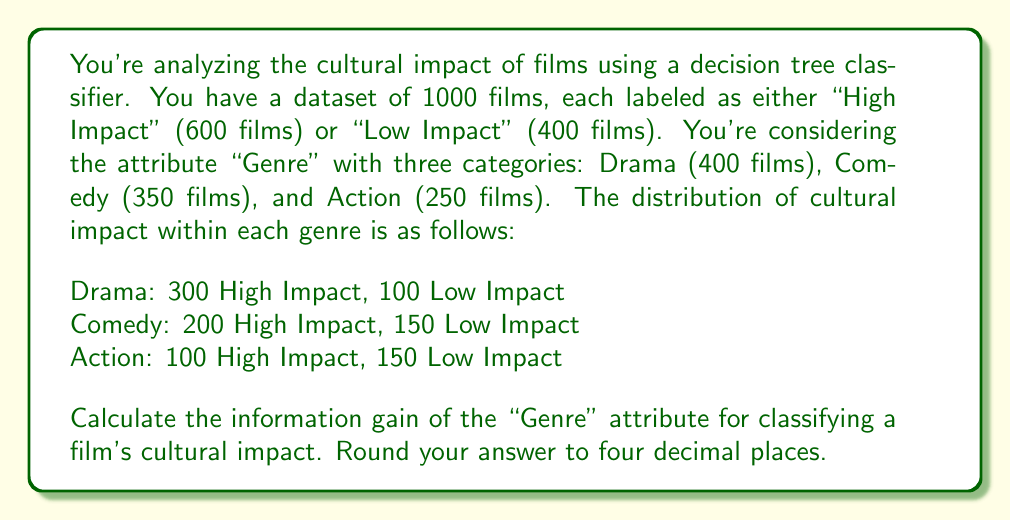Teach me how to tackle this problem. To calculate the information gain, we need to follow these steps:

1. Calculate the entropy of the parent node (before splitting)
2. Calculate the weighted entropy of the child nodes (after splitting)
3. Subtract the weighted entropy from the parent entropy

Step 1: Entropy of the parent node

The entropy is calculated using the formula:
$$ H(S) = -\sum_{i=1}^{n} p_i \log_2(p_i) $$

Where $p_i$ is the probability of each class.

$p(\text{High Impact}) = 600/1000 = 0.6$
$p(\text{Low Impact}) = 400/1000 = 0.4$

$$ H(S) = -[0.6 \log_2(0.6) + 0.4 \log_2(0.4)] = 0.9710 \text{ bits} $$

Step 2: Weighted entropy of child nodes

For each genre, we calculate the entropy:

Drama:
$p(\text{High}|\text{Drama}) = 300/400 = 0.75$
$p(\text{Low}|\text{Drama}) = 100/400 = 0.25$
$$ H(\text{Drama}) = -[0.75 \log_2(0.75) + 0.25 \log_2(0.25)] = 0.8113 \text{ bits} $$

Comedy:
$p(\text{High}|\text{Comedy}) = 200/350 \approx 0.5714$
$p(\text{Low}|\text{Comedy}) = 150/350 \approx 0.4286$
$$ H(\text{Comedy}) = -[0.5714 \log_2(0.5714) + 0.4286 \log_2(0.4286)] = 0.9852 \text{ bits} $$

Action:
$p(\text{High}|\text{Action}) = 100/250 = 0.4$
$p(\text{Low}|\text{Action}) = 150/250 = 0.6$
$$ H(\text{Action}) = -[0.4 \log_2(0.4) + 0.6 \log_2(0.6)] = 0.9710 \text{ bits} $$

Now, we calculate the weighted entropy:
$$ H(\text{Genre}) = \frac{400}{1000} H(\text{Drama}) + \frac{350}{1000} H(\text{Comedy}) + \frac{250}{1000} H(\text{Action}) $$
$$ H(\text{Genre}) = 0.4 \times 0.8113 + 0.35 \times 0.9852 + 0.25 \times 0.9710 = 0.9147 \text{ bits} $$

Step 3: Information Gain

The information gain is the difference between the parent entropy and the weighted child entropy:

$$ \text{IG(Genre)} = H(S) - H(\text{Genre}) = 0.9710 - 0.9147 = 0.0563 \text{ bits} $$

Rounding to four decimal places, we get 0.0563 bits.
Answer: 0.0563 bits 